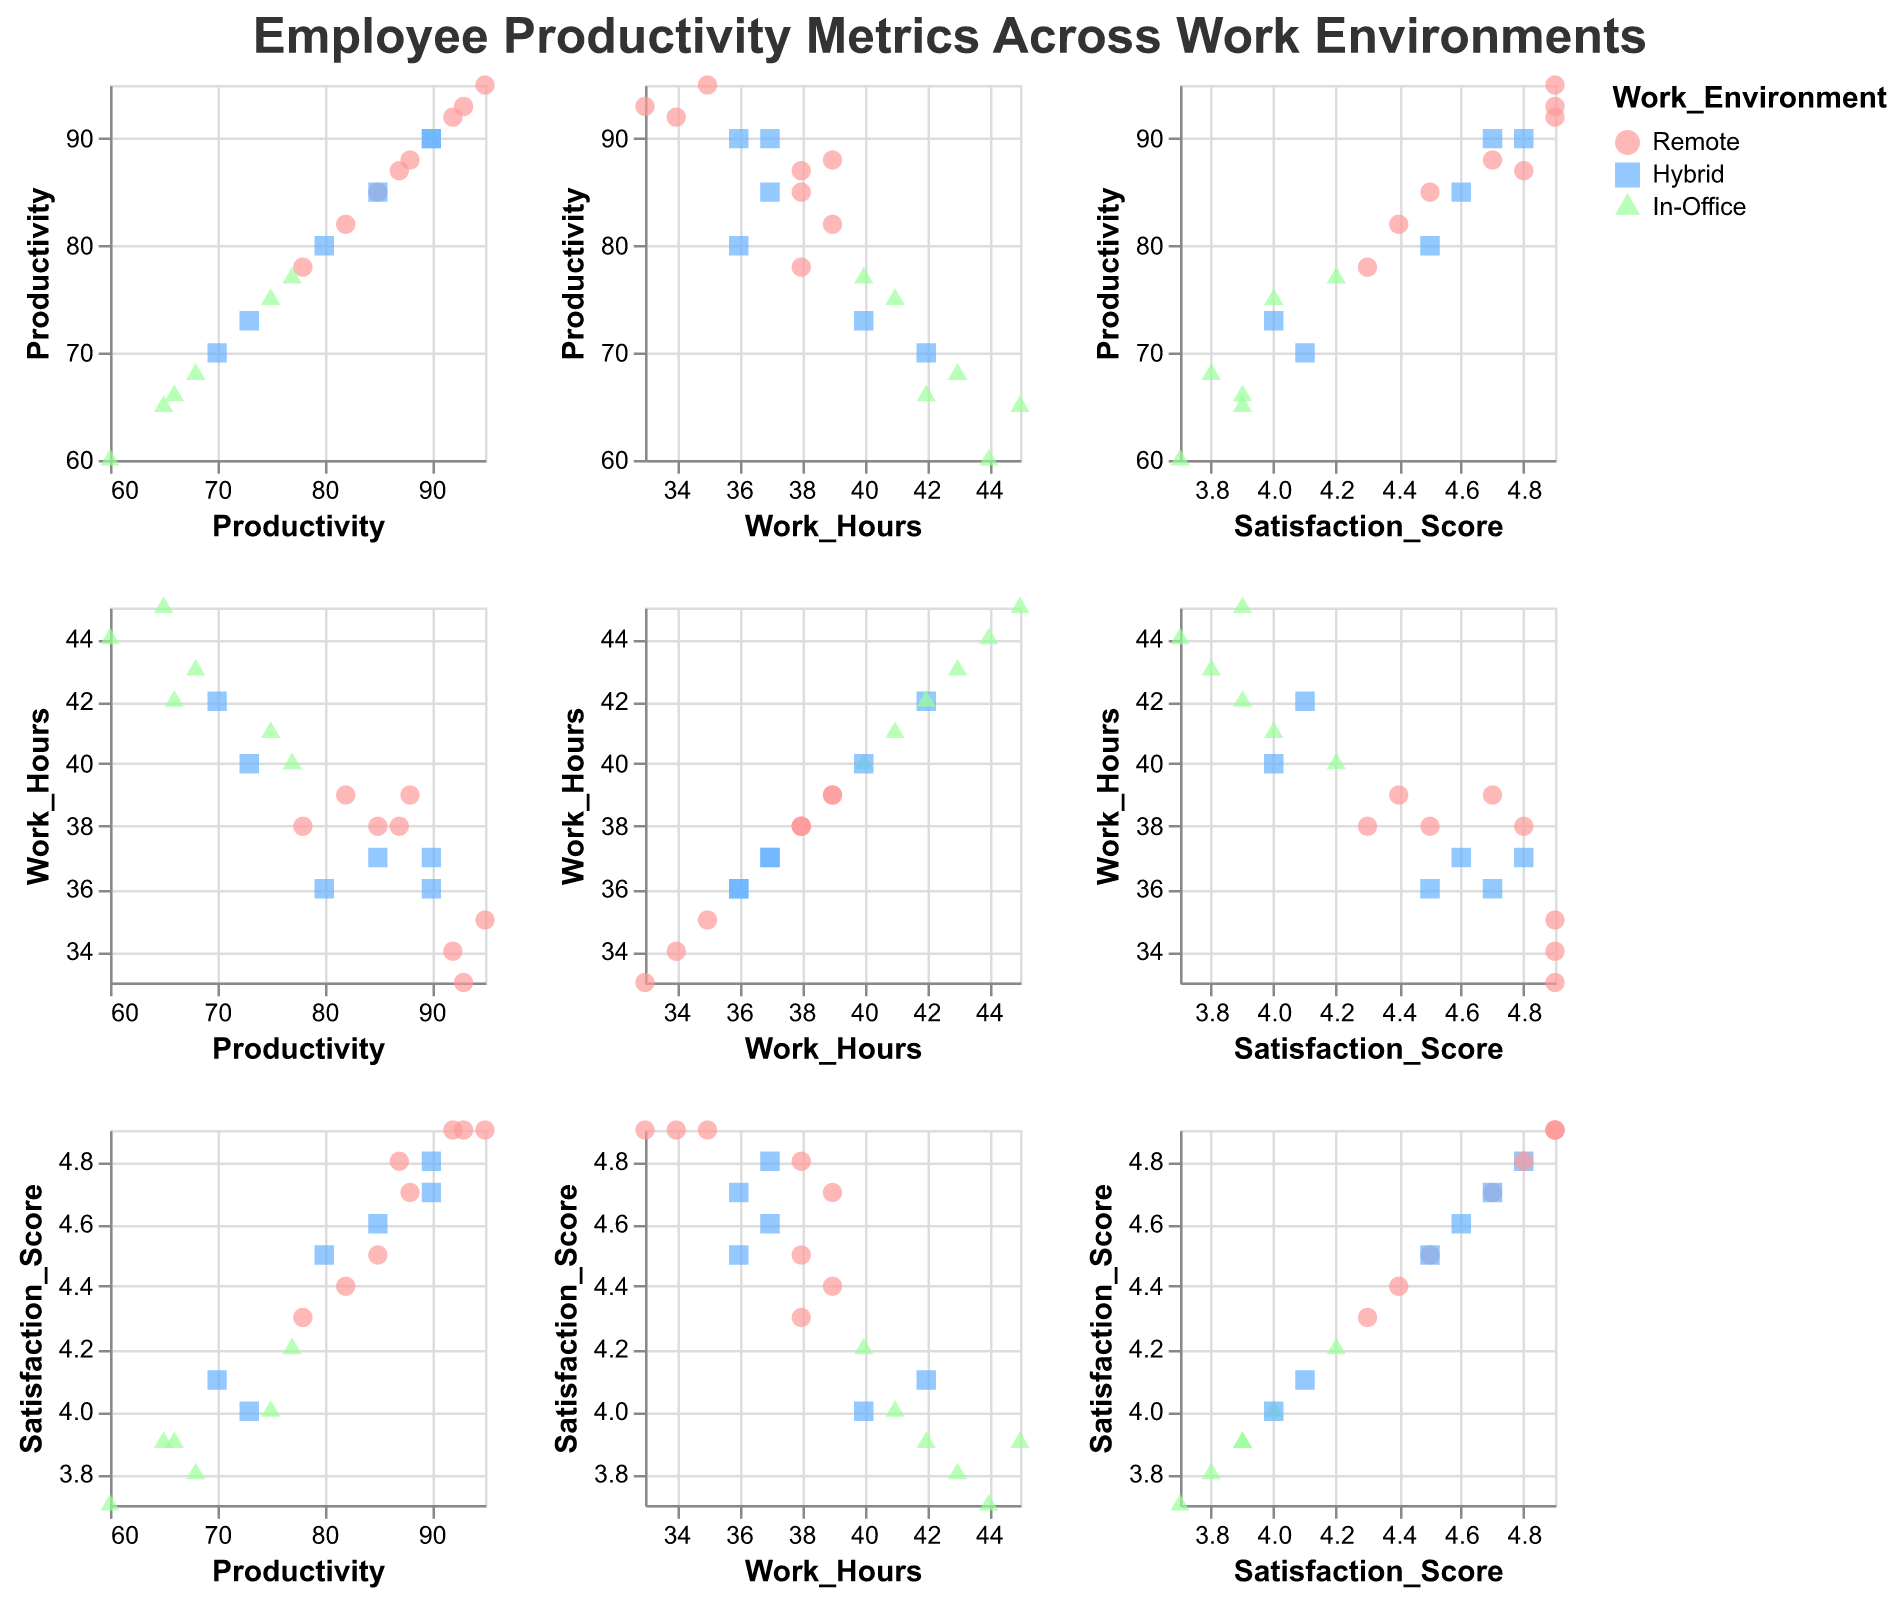What is the highest productivity score recorded in the "Remote" work environment? Locate all the data points colored red, which represent the "Remote" work environment. Identify the highest productivity score among these points.
Answer: 95 Which data point has the highest satisfaction score, and what is the corresponding work environment for that data point? Find the highest y-value on the Satisfaction_Score axis. The tooltip of the corresponding point will show the Satisfaction_Score and Work_Environment.
Answer: Remote In which work environment do employees have the highest average productivity? Calculate the average productivity for each work environment. Sum the productivity scores for each group and divide by the number of employees in that group. Remote: (85 + 95 + 88 + 92 + 78 + 82 + 87 + 93) / 8 = 700 / 8 = 87.5. Hybrid: (90 + 70 + 80 + 85 + 73 + 90) / 6 = 488 / 6 = 81.33. In-Office: (77 + 65 + 75 + 68 + 60 + 66) / 6 = 411 / 6 = 68.5. Therefore, the work environment with the highest average productivity is Remote.
Answer: Remote How does the satisfaction score relate to work hours in the "In-Office" work environment? Highlight the green triangles, which represent "In-Office." Observe the spread of Satisfaction_Score against Work_Hours. Satisfaction_Scores tend to be lower and Work_Hours higher compared to other environments. Several points are grouped around average values, so the general trend is a negative correlation.
Answer: Generally, lower satisfaction score with higher work hours What is the range of productivity scores for the "Hybrid" work environment? Identify the blue squares which represent the "Hybrid" work environment. Note the smallest and largest Productivity values among these points. The smallest value is 70, and the largest is 90.
Answer: 70-90 